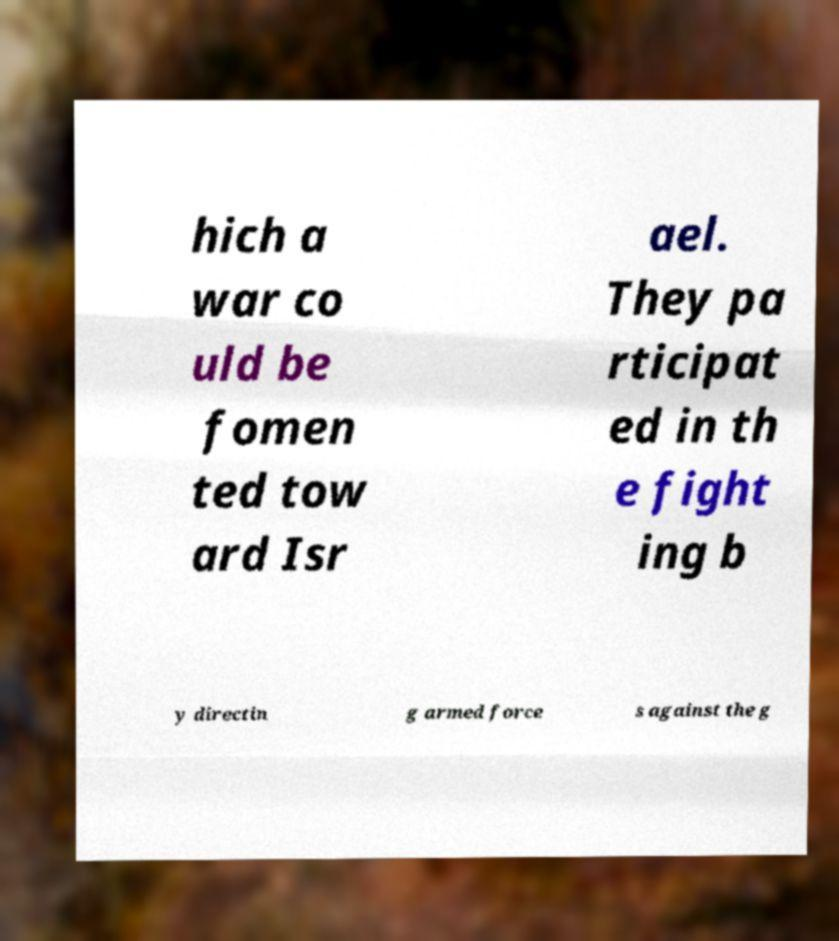Can you read and provide the text displayed in the image?This photo seems to have some interesting text. Can you extract and type it out for me? hich a war co uld be fomen ted tow ard Isr ael. They pa rticipat ed in th e fight ing b y directin g armed force s against the g 